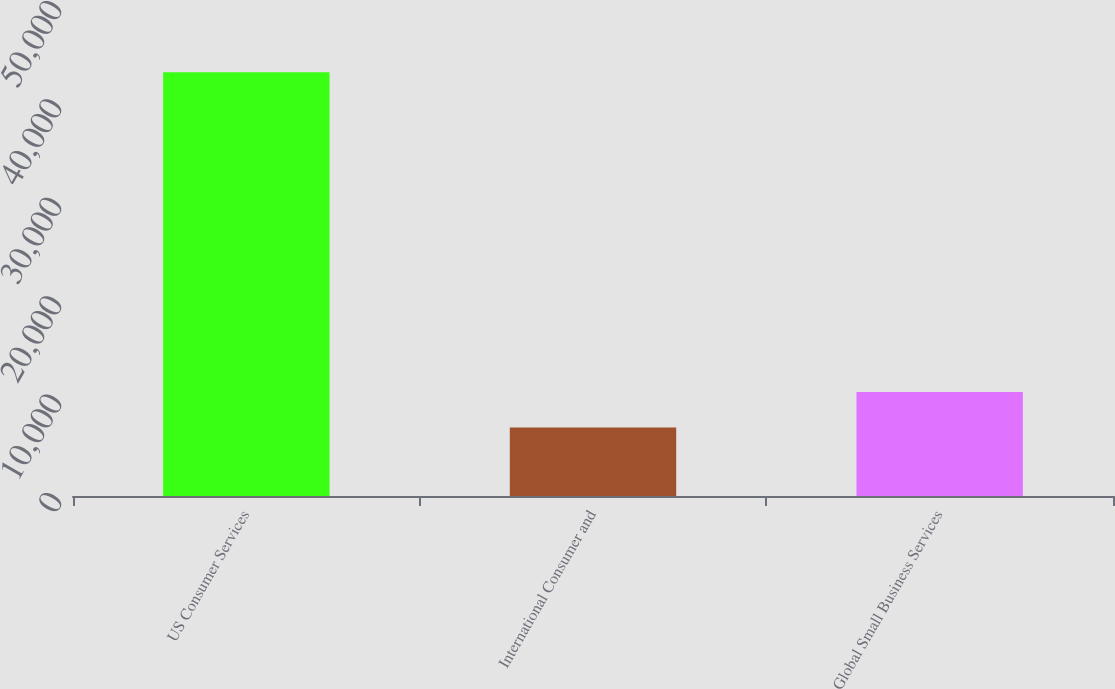<chart> <loc_0><loc_0><loc_500><loc_500><bar_chart><fcel>US Consumer Services<fcel>International Consumer and<fcel>Global Small Business Services<nl><fcel>43063<fcel>6961<fcel>10571.2<nl></chart> 